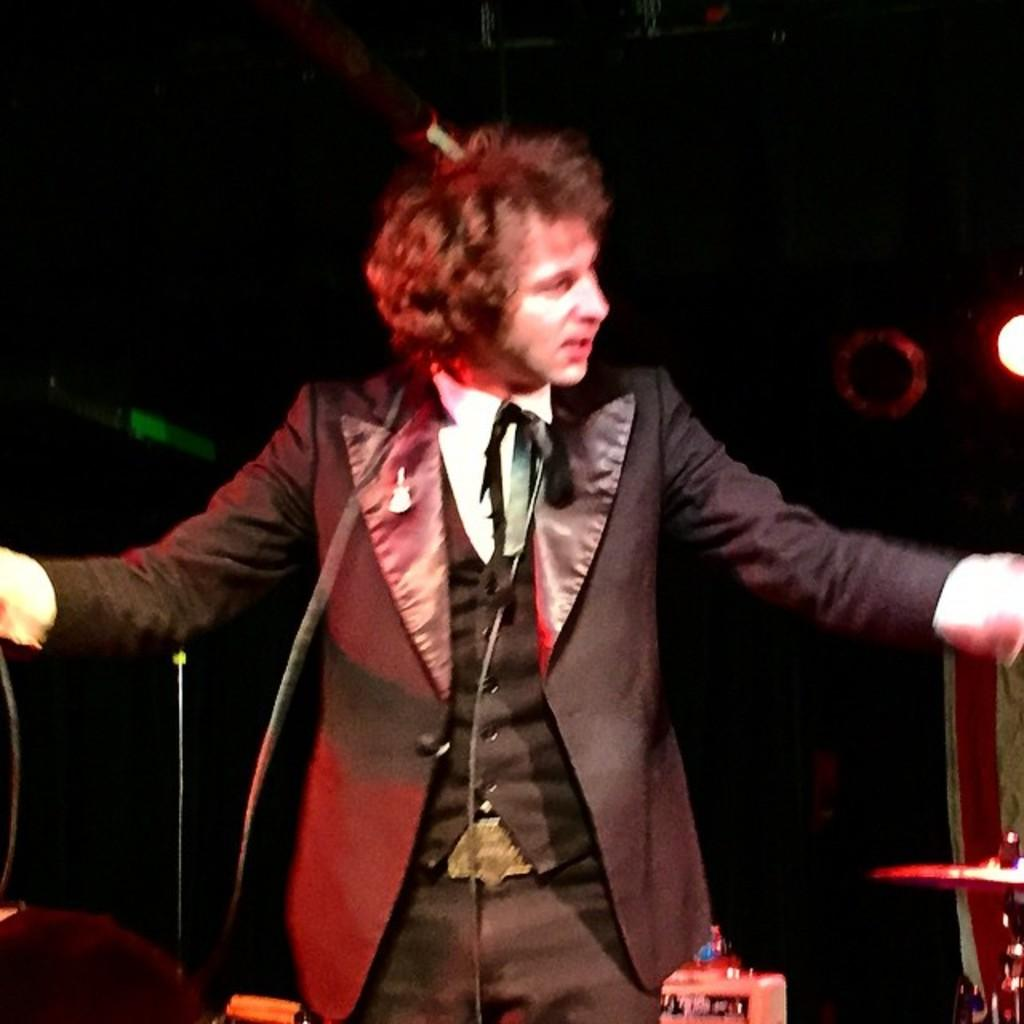What is the main subject of the image? The main subject of the image is a man standing. Can you describe the background of the image? The background of the image is dark. How far away is the monkey in the image? There is no monkey present in the image. What type of chess piece is the man holding in the image? The man is not holding any chess pieces in the image. 